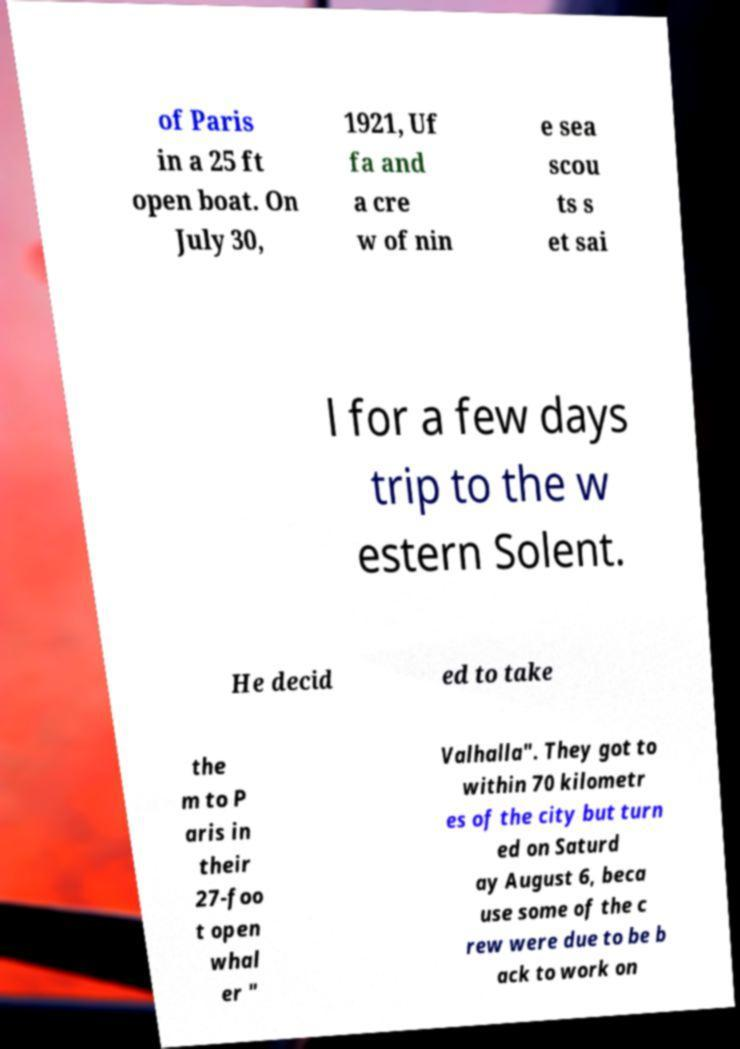Could you extract and type out the text from this image? of Paris in a 25 ft open boat. On July 30, 1921, Uf fa and a cre w of nin e sea scou ts s et sai l for a few days trip to the w estern Solent. He decid ed to take the m to P aris in their 27-foo t open whal er " Valhalla". They got to within 70 kilometr es of the city but turn ed on Saturd ay August 6, beca use some of the c rew were due to be b ack to work on 